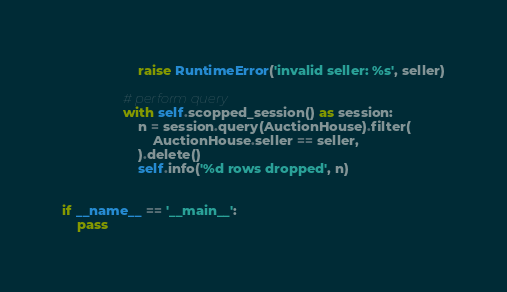Convert code to text. <code><loc_0><loc_0><loc_500><loc_500><_Python_>                    raise RuntimeError('invalid seller: %s', seller)

                # perform query
                with self.scopped_session() as session:
                    n = session.query(AuctionHouse).filter(
                        AuctionHouse.seller == seller,
                    ).delete()
                    self.info('%d rows dropped', n)


if __name__ == '__main__':
    pass
</code> 